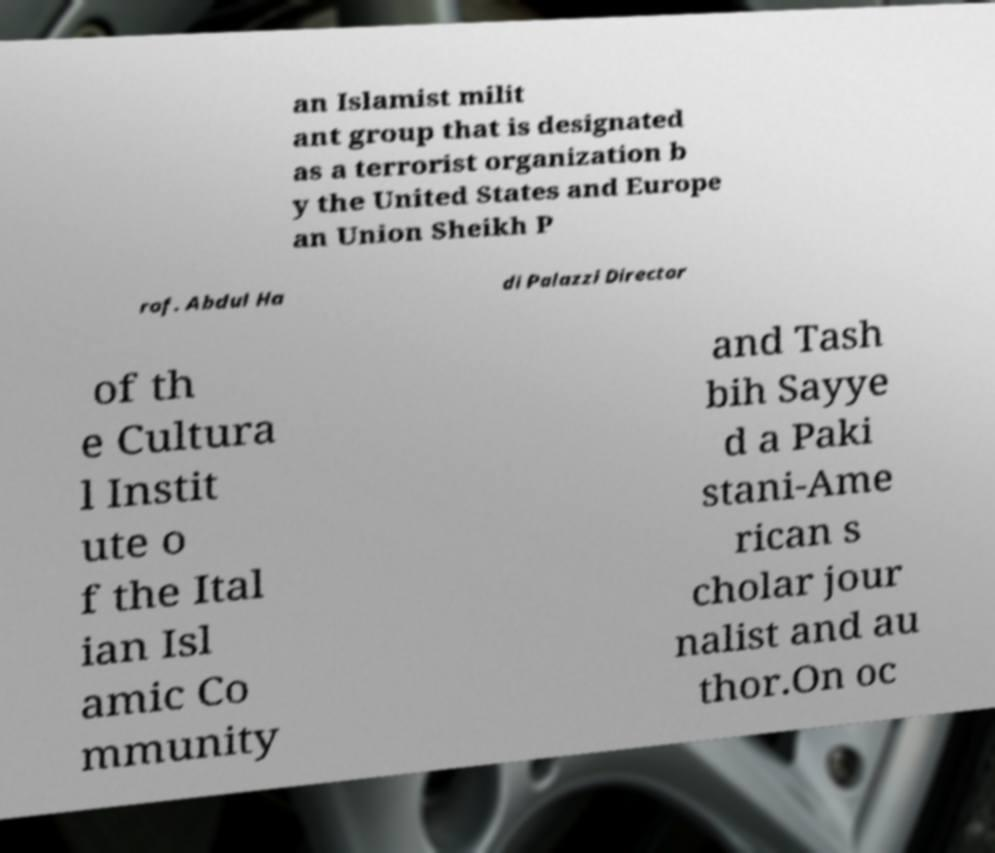Can you accurately transcribe the text from the provided image for me? an Islamist milit ant group that is designated as a terrorist organization b y the United States and Europe an Union Sheikh P rof. Abdul Ha di Palazzi Director of th e Cultura l Instit ute o f the Ital ian Isl amic Co mmunity and Tash bih Sayye d a Paki stani-Ame rican s cholar jour nalist and au thor.On oc 